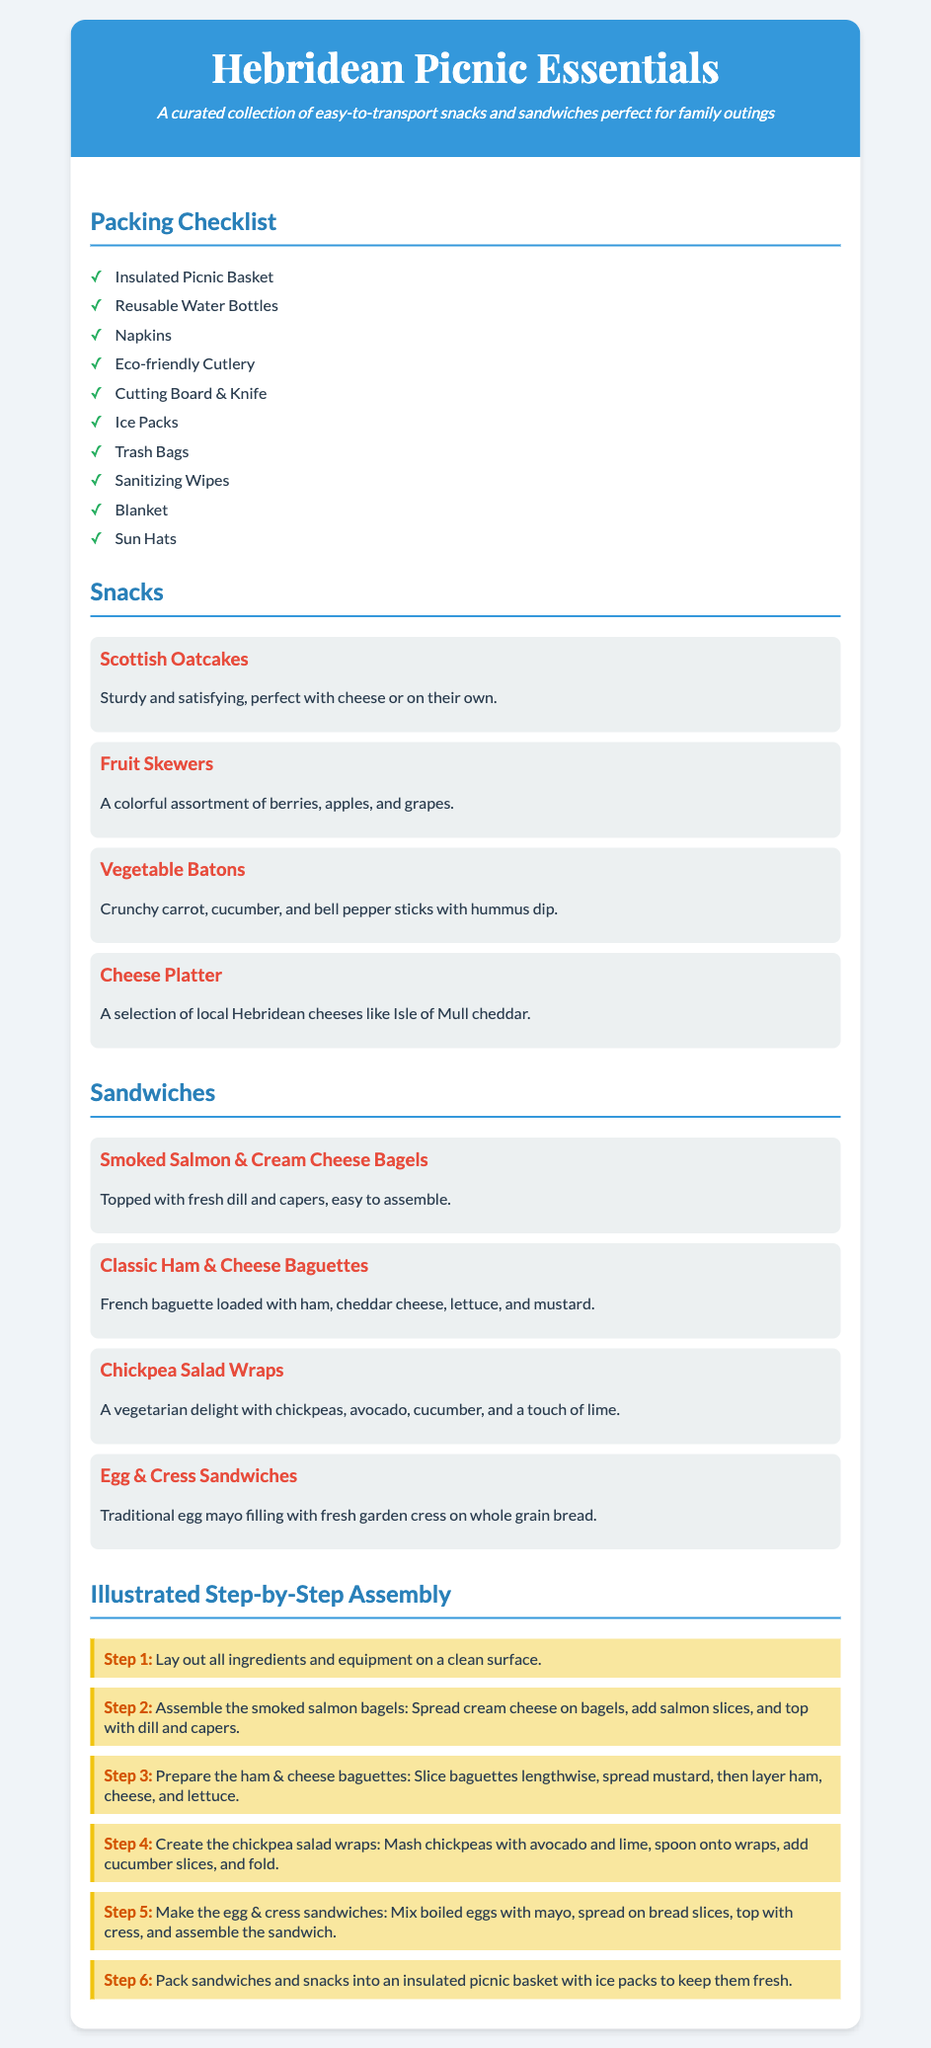What is the title of the document? The title is prominently displayed at the top of the document.
Answer: Hebridean Picnic Essentials How many snack items are listed? The number of snack items can be counted in the Snacks section of the document.
Answer: 4 What is the first step in the assembly process? The steps for assembly are clearly numbered and detailed in the document.
Answer: Lay out all ingredients and equipment on a clean surface Name one item from the Packing Checklist. Items in the packing checklist are listed in a bullet format.
Answer: Insulated Picnic Basket Which sandwich contains smoked salmon? The name of the sandwich is explicitly mentioned in the Sandwiches section.
Answer: Smoked Salmon & Cream Cheese Bagels What type of cheese is mentioned in the cheese platter? A specific cheese type is noted in the description of the cheese platter.
Answer: Isle of Mull cheddar How many sandwiches are listed? Count the sandwiches presented in the Sandwiches section of the document.
Answer: 4 What color is the header background? The header background color is stated in the style section of the document.
Answer: Blue 